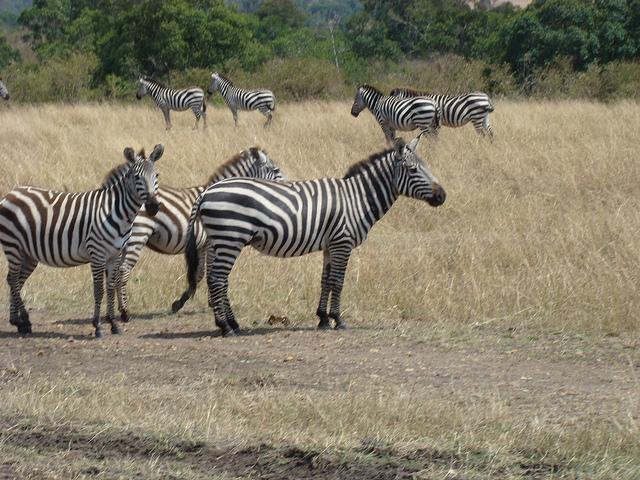How many zebra are there total in the picture?
Give a very brief answer. 7. How many zebras are there?
Give a very brief answer. 5. 